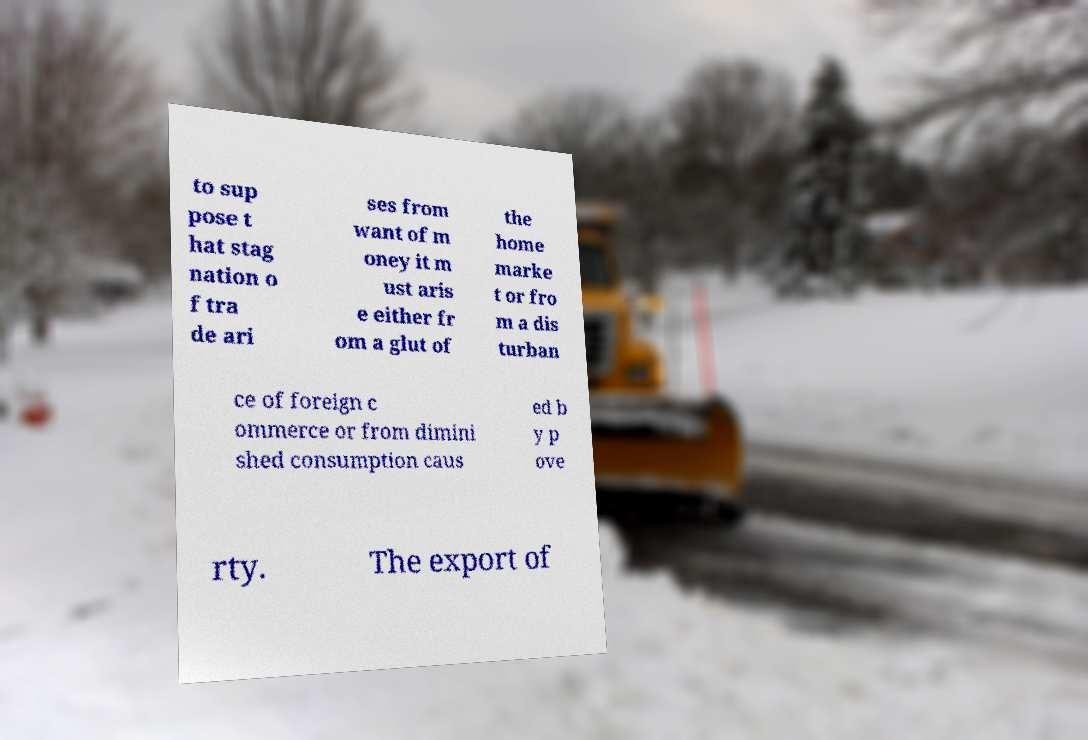Please read and relay the text visible in this image. What does it say? to sup pose t hat stag nation o f tra de ari ses from want of m oney it m ust aris e either fr om a glut of the home marke t or fro m a dis turban ce of foreign c ommerce or from dimini shed consumption caus ed b y p ove rty. The export of 